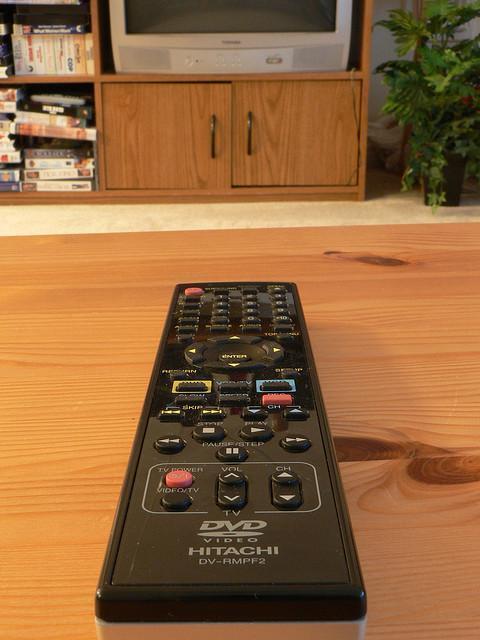How many potted plants are visible?
Give a very brief answer. 1. 